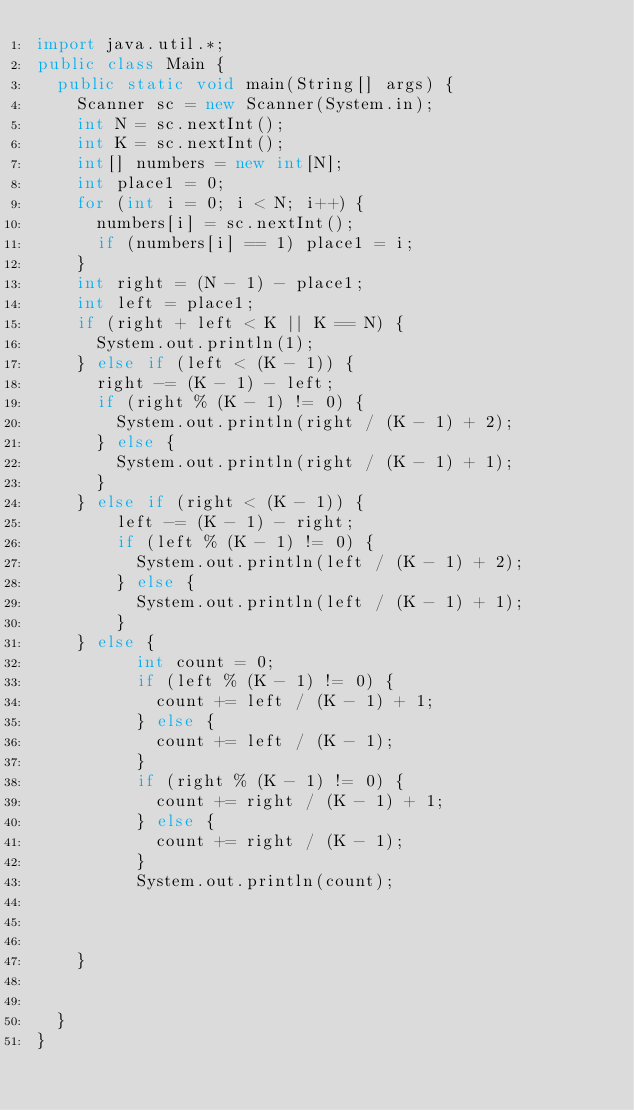Convert code to text. <code><loc_0><loc_0><loc_500><loc_500><_Java_>import java.util.*;
public class Main {
  public static void main(String[] args) {
    Scanner sc = new Scanner(System.in);
    int N = sc.nextInt();
    int K = sc.nextInt();
    int[] numbers = new int[N];
    int place1 = 0;
    for (int i = 0; i < N; i++) {
      numbers[i] = sc.nextInt();
      if (numbers[i] == 1) place1 = i;
    }
    int right = (N - 1) - place1;
    int left = place1;
    if (right + left < K || K == N) {
      System.out.println(1);
    } else if (left < (K - 1)) {
      right -= (K - 1) - left;
      if (right % (K - 1) != 0) {
        System.out.println(right / (K - 1) + 2);
      } else {
        System.out.println(right / (K - 1) + 1);
      }
    } else if (right < (K - 1)) {
        left -= (K - 1) - right;
        if (left % (K - 1) != 0) {
          System.out.println(left / (K - 1) + 2);
        } else {
          System.out.println(left / (K - 1) + 1);
        }
    } else {
          int count = 0;
          if (left % (K - 1) != 0) {
            count += left / (K - 1) + 1;
          } else {
            count += left / (K - 1);
          }
          if (right % (K - 1) != 0) {
            count += right / (K - 1) + 1;
          } else {
            count += right / (K - 1);
          }
          System.out.println(count);
        
      
      
    }
    
    
  }
}</code> 